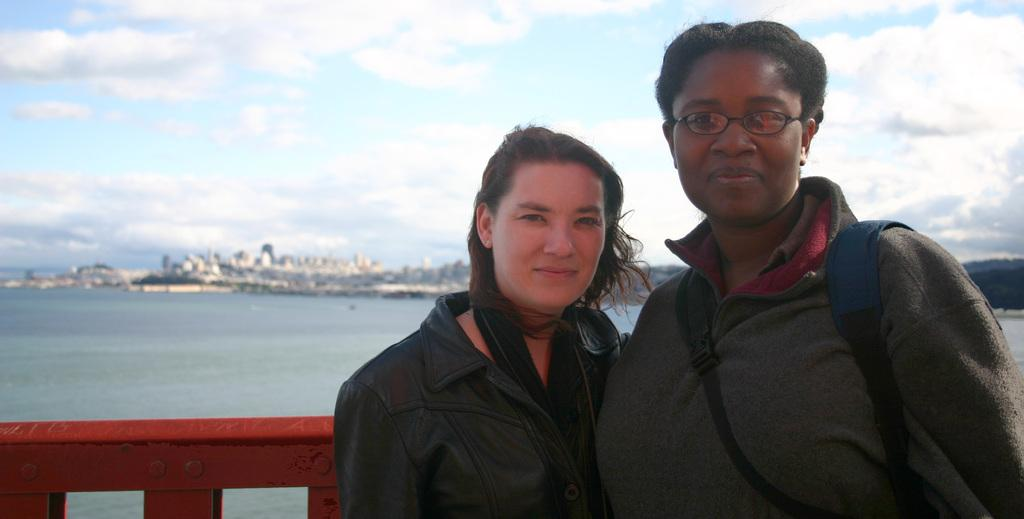Who can be seen in the image? There are two women standing at the fence. What is visible in the background of the image? Water, buildings, and objects can be seen in the background. What is the condition of the sky in the image? There are clouds in the sky in the background. What is the purpose of the celery in the image? A: There is no celery present in the image. 